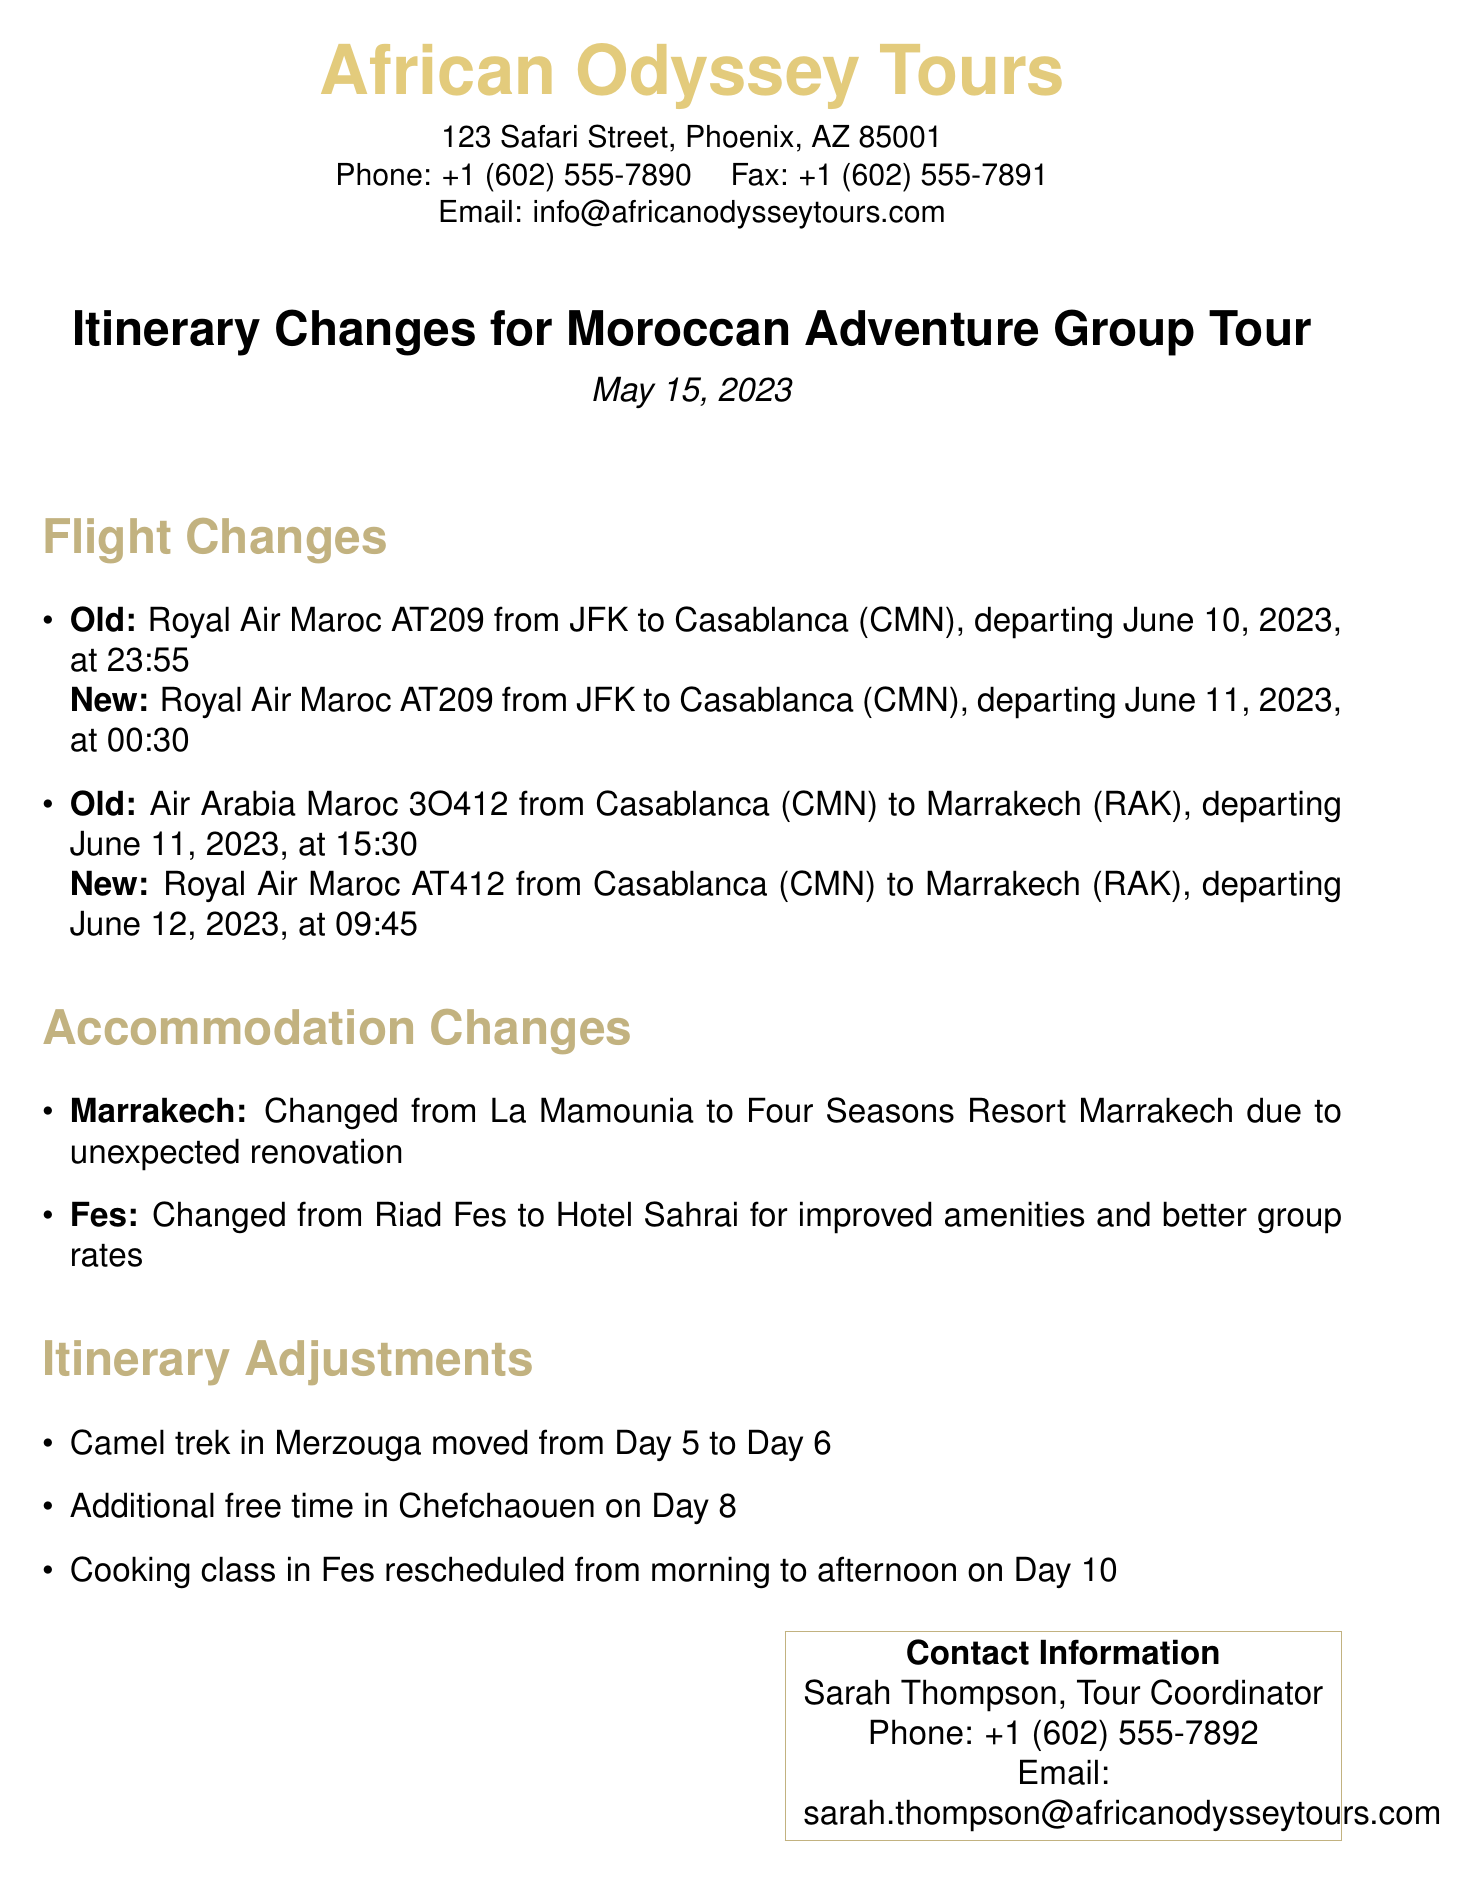What is the departure date for the flight from JFK to Casablanca? The document states the new departure date for the flight is June 11, 2023, at 00:30.
Answer: June 11, 2023, at 00:30 Which airline is responsible for the flight from Casablanca to Marrakech? The document indicates that Royal Air Maroc is the airline for the flight from Casablanca to Marrakech.
Answer: Royal Air Maroc What is the reason for changing accommodation in Marrakech? The document explains that the change from La Mamounia to Four Seasons Resort Marrakech is due to unexpected renovation.
Answer: Unexpected renovation On which day is the camel trek now scheduled? The document mentions that the camel trek in Merzouga has moved to Day 6.
Answer: Day 6 What improvements are offered by the new accommodation in Fes? The document notes that the switch to Hotel Sahrai offers improved amenities and better group rates.
Answer: Improved amenities and better group rates What time was the cooking class rescheduled to? According to the document, the cooking class in Fes was rescheduled to the afternoon on Day 10.
Answer: Afternoon on Day 10 Who should be contacted for more information regarding the tour? The document provides the contact information for Sarah Thompson, the Tour Coordinator, who should be reached for inquiries.
Answer: Sarah Thompson What was the old flight number for the flight from Casablanca to Marrakech? The document specifies that the old flight number was Air Arabia Maroc 3O412 for the flight from Casablanca to Marrakech.
Answer: Air Arabia Maroc 3O412 